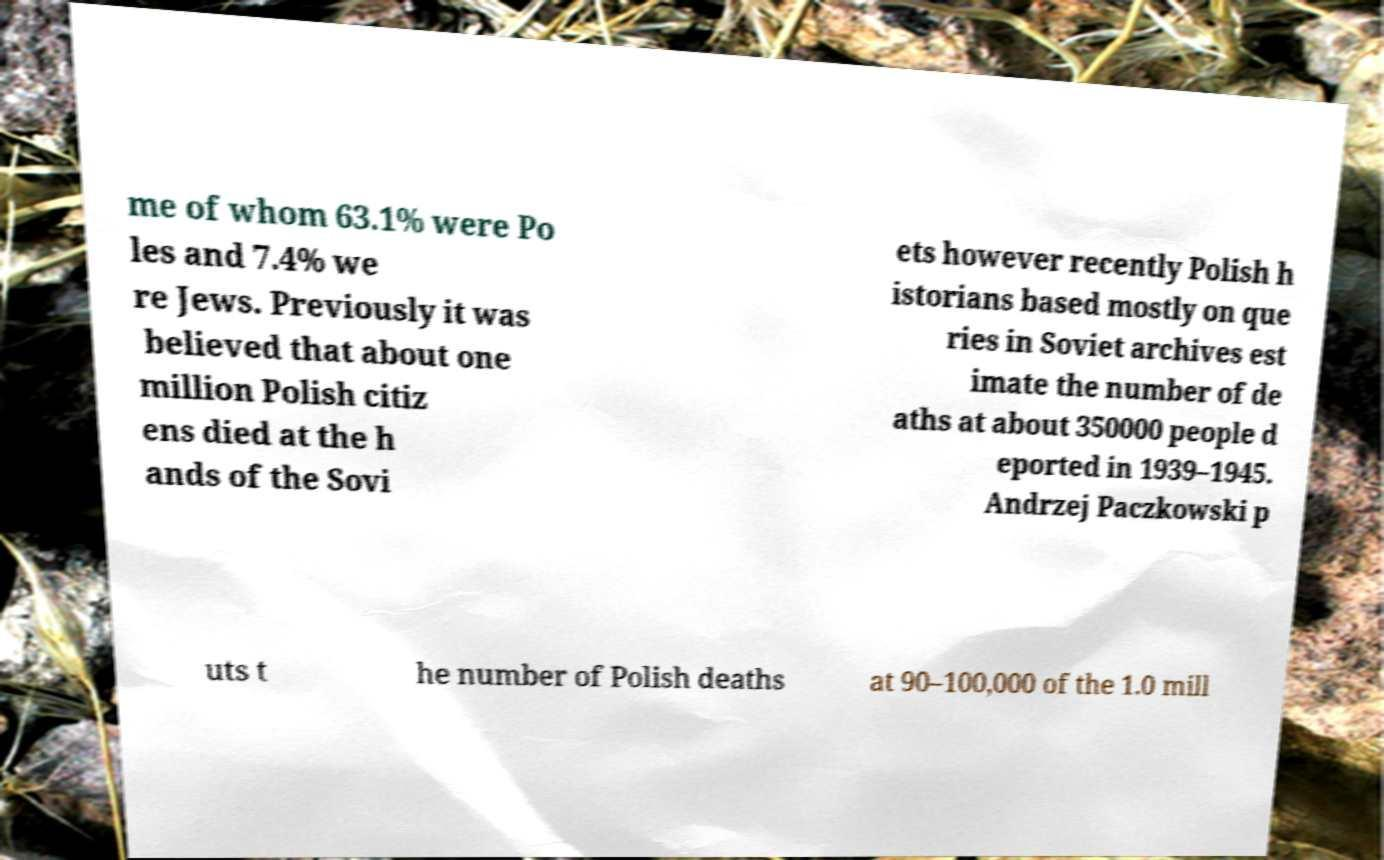Can you read and provide the text displayed in the image?This photo seems to have some interesting text. Can you extract and type it out for me? me of whom 63.1% were Po les and 7.4% we re Jews. Previously it was believed that about one million Polish citiz ens died at the h ands of the Sovi ets however recently Polish h istorians based mostly on que ries in Soviet archives est imate the number of de aths at about 350000 people d eported in 1939–1945. Andrzej Paczkowski p uts t he number of Polish deaths at 90–100,000 of the 1.0 mill 